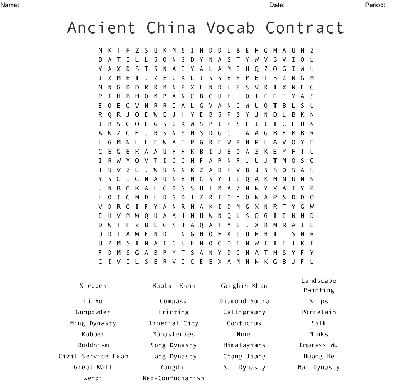Identify some specific historical or cultural terms visible in this word search. The word search includes terms like 'Dynasty,' 'Silk' (referring to the Silk Road), and 'Great Wall,' all of which are significant to understanding Ancient China's history and its impact on trade and military strategies. How does the inclusion of the Great Wall reflect on Chinese history? The Great Wall reflects China's historical defensive strategies against invasions and its engineering prowess. It's a symbol of national strength and a critical landmark in Chinese cultural heritage. 